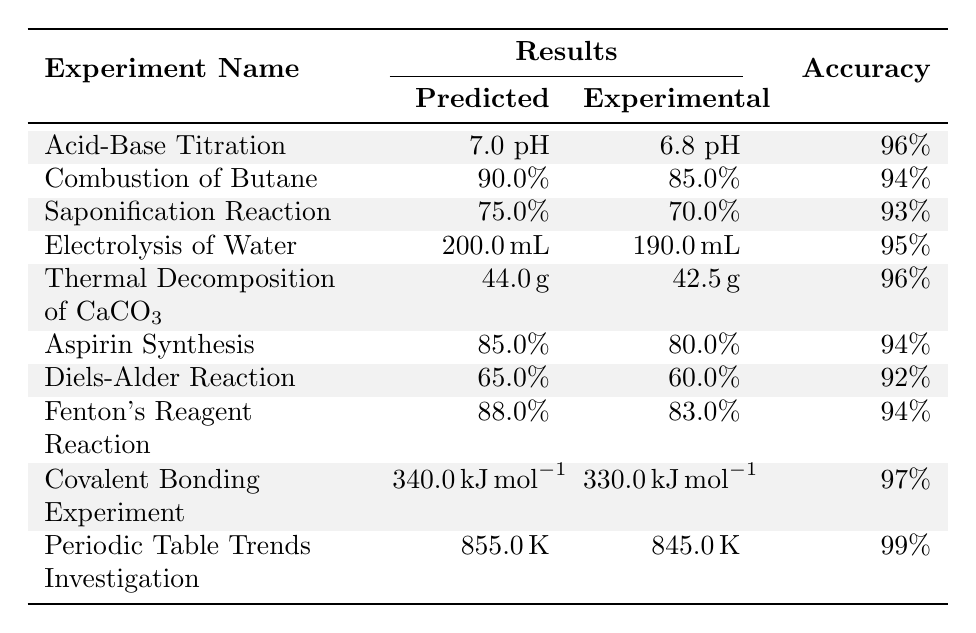What is the predicted pH value for the Acid-Base Titration experiment? The table shows the predicted pH value under the "Predicted" column for the Acid-Base Titration experiment, which is 7.0.
Answer: 7.0 What is the accuracy of the Electrolysis of Water experiment? The accuracy for the Electrolysis of Water experiment is located in the "Accuracy" column, which states 95%.
Answer: 95% What was the experimental yield for the Aspirin Synthesis experiment? The experimental yield can be found in the "Experimental" column for the Aspirin Synthesis experiment, which shows 80.0%.
Answer: 80.0% How much hydrogen volume was predicted in the Electrolysis of Water experiment? Referring to the "Predicted" column for the Electrolysis of Water experiment, the hydrogen volume predicted is 200.0 milliliters.
Answer: 200.0 milliliters What is the difference between the predicted yield and actual yield for the Diels-Alder Reaction? The predicted yield is 65.0%, and the actual yield is 60.0%. The difference is calculated as 65.0% - 60.0% = 5.0%.
Answer: 5.0% Which experiment has the highest prediction accuracy? By reviewing the "Accuracy" values for all experiments, the Periodic Table Trends Investigation has the highest accuracy of 99%.
Answer: 99% Is the experimental mass loss in the Thermal Decomposition of Calcium Carbonate greater than 40 grams? The experimental mass loss reported is 42.5 grams, which is greater than 40 grams.
Answer: Yes Which experiment had a predicted yield of 75.0%? The Saponification Reaction had a predicted yield listed as 75.0% in the "Predicted" column.
Answer: Saponification Reaction What are the average predicted yields for the two experiments in the table with the lowest prediction accuracy? The two experiments with the lowest accuracy are the Diels-Alder Reaction (92%) and Saponification Reaction (93%). Their corresponding predicted yields are 65.0% and 75.0%. The average is calculated as (65.0% + 75.0%) / 2 = 70.0%.
Answer: 70.0% Which experiment has the lowest experimental yield? The Diels-Alder Reaction has the lowest experimental yield at 60.0% as seen in the table.
Answer: 60.0% 